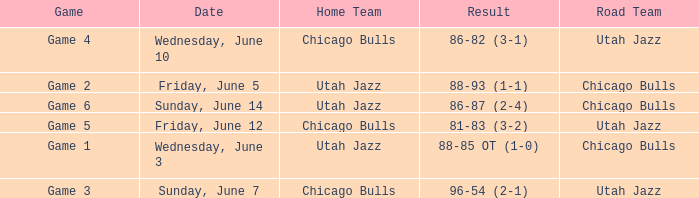Home Team of chicago bulls, and a Result of 81-83 (3-2) involved what game? Game 5. 